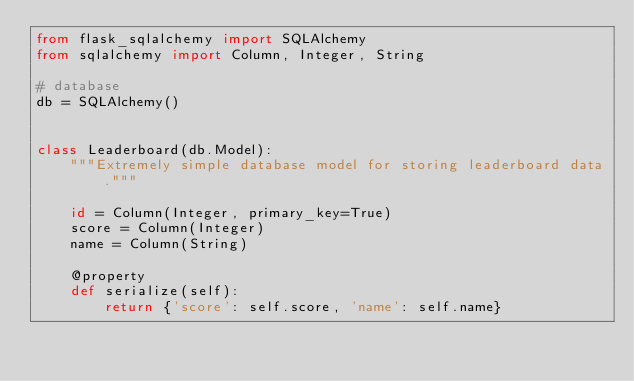<code> <loc_0><loc_0><loc_500><loc_500><_Python_>from flask_sqlalchemy import SQLAlchemy
from sqlalchemy import Column, Integer, String

# database
db = SQLAlchemy()


class Leaderboard(db.Model):
    """Extremely simple database model for storing leaderboard data."""

    id = Column(Integer, primary_key=True)
    score = Column(Integer)
    name = Column(String)

    @property
    def serialize(self):
        return {'score': self.score, 'name': self.name}
</code> 